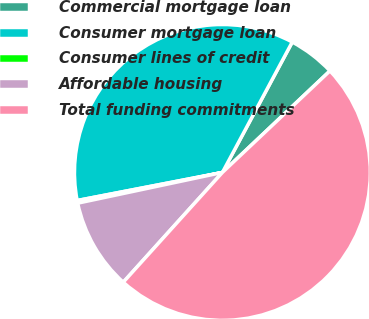Convert chart to OTSL. <chart><loc_0><loc_0><loc_500><loc_500><pie_chart><fcel>Commercial mortgage loan<fcel>Consumer mortgage loan<fcel>Consumer lines of credit<fcel>Affordable housing<fcel>Total funding commitments<nl><fcel>5.13%<fcel>35.87%<fcel>0.29%<fcel>9.98%<fcel>48.74%<nl></chart> 